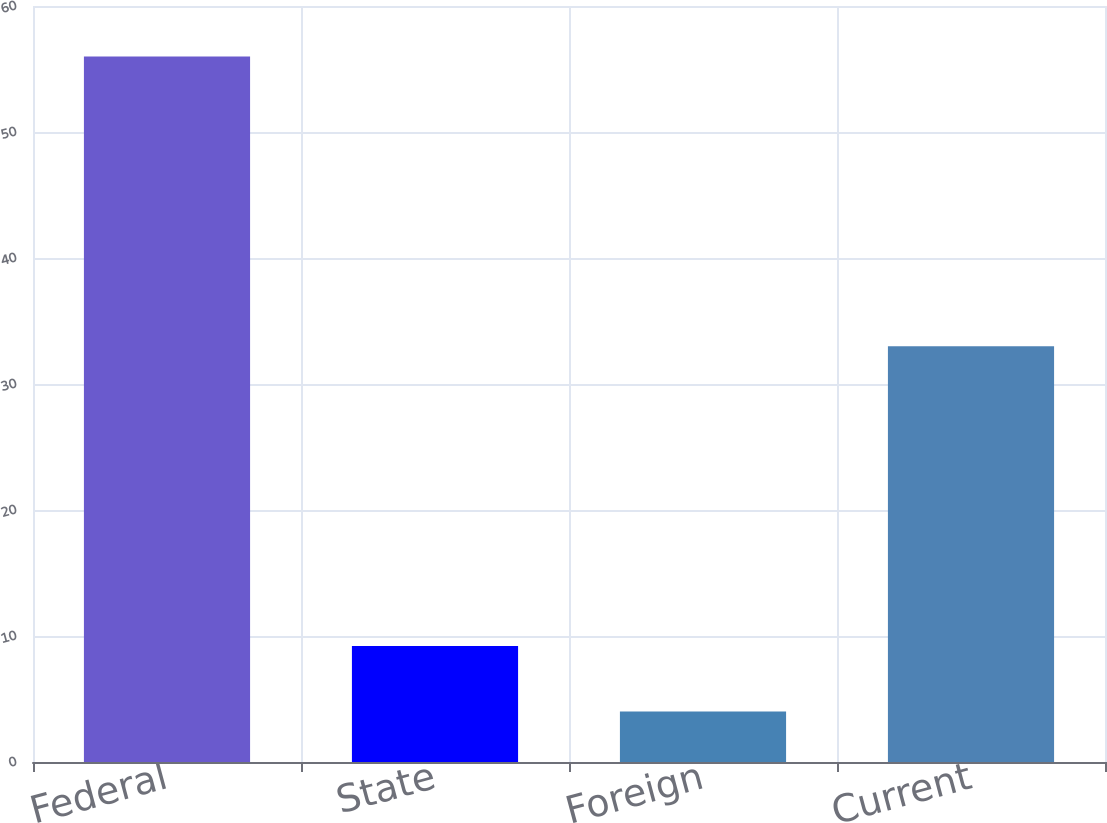<chart> <loc_0><loc_0><loc_500><loc_500><bar_chart><fcel>Federal<fcel>State<fcel>Foreign<fcel>Current<nl><fcel>56<fcel>9.2<fcel>4<fcel>33<nl></chart> 